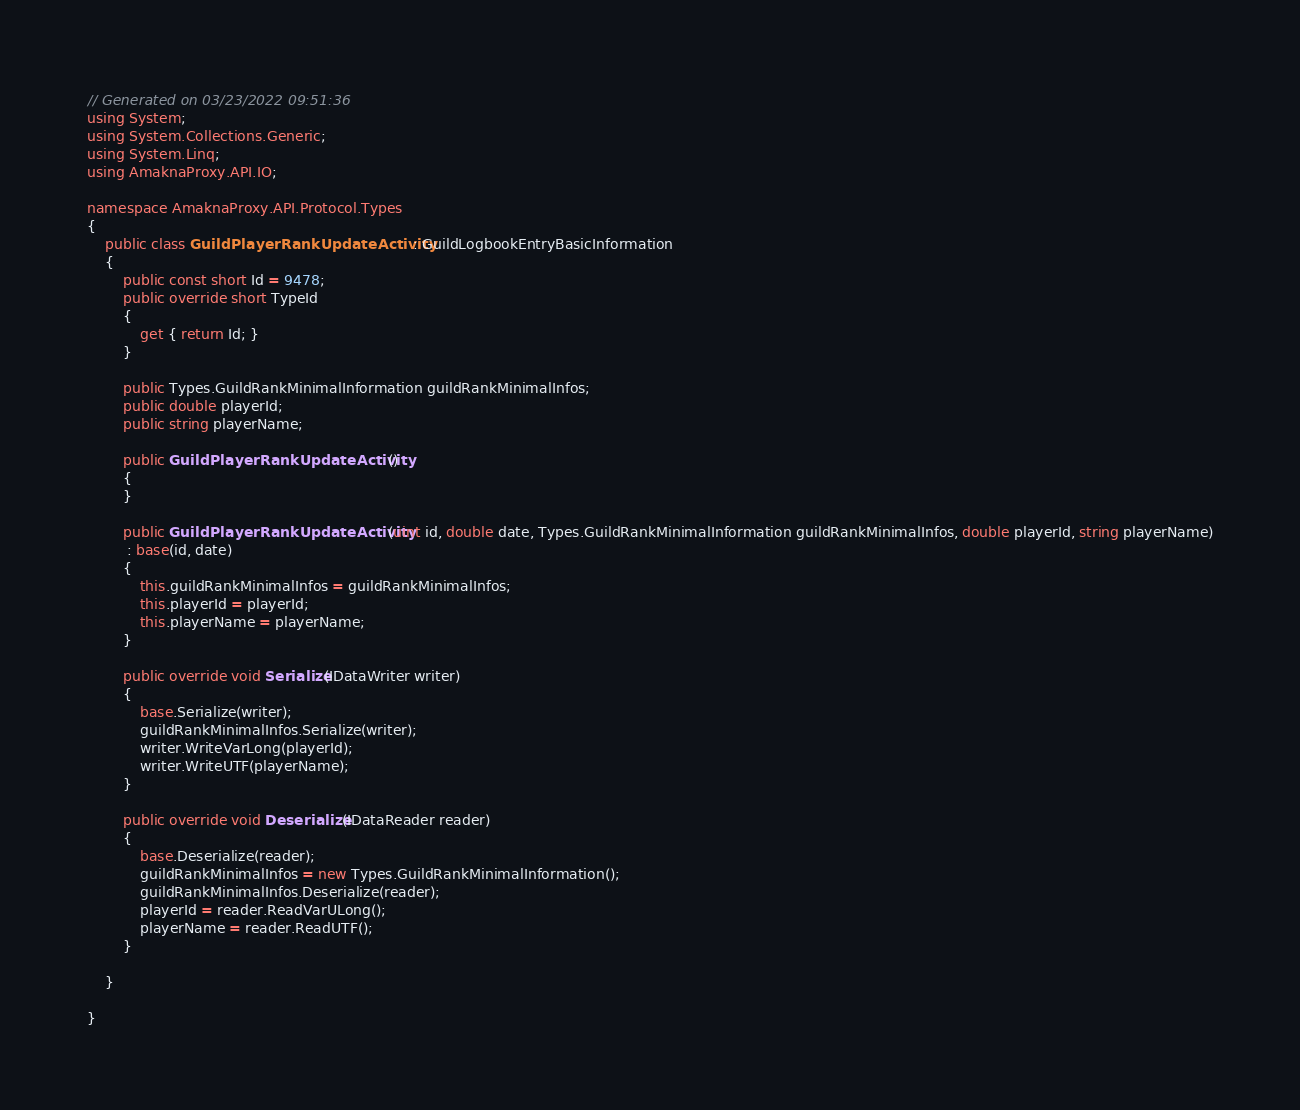Convert code to text. <code><loc_0><loc_0><loc_500><loc_500><_C#_>

// Generated on 03/23/2022 09:51:36
using System;
using System.Collections.Generic;
using System.Linq;
using AmaknaProxy.API.IO;

namespace AmaknaProxy.API.Protocol.Types
{
    public class GuildPlayerRankUpdateActivity : GuildLogbookEntryBasicInformation
    {
        public const short Id = 9478;
        public override short TypeId
        {
            get { return Id; }
        }
        
        public Types.GuildRankMinimalInformation guildRankMinimalInfos;
        public double playerId;
        public string playerName;
        
        public GuildPlayerRankUpdateActivity()
        {
        }
        
        public GuildPlayerRankUpdateActivity(uint id, double date, Types.GuildRankMinimalInformation guildRankMinimalInfos, double playerId, string playerName)
         : base(id, date)
        {
            this.guildRankMinimalInfos = guildRankMinimalInfos;
            this.playerId = playerId;
            this.playerName = playerName;
        }
        
        public override void Serialize(IDataWriter writer)
        {
            base.Serialize(writer);
            guildRankMinimalInfos.Serialize(writer);
            writer.WriteVarLong(playerId);
            writer.WriteUTF(playerName);
        }
        
        public override void Deserialize(IDataReader reader)
        {
            base.Deserialize(reader);
            guildRankMinimalInfos = new Types.GuildRankMinimalInformation();
            guildRankMinimalInfos.Deserialize(reader);
            playerId = reader.ReadVarULong();
            playerName = reader.ReadUTF();
        }
        
    }
    
}</code> 